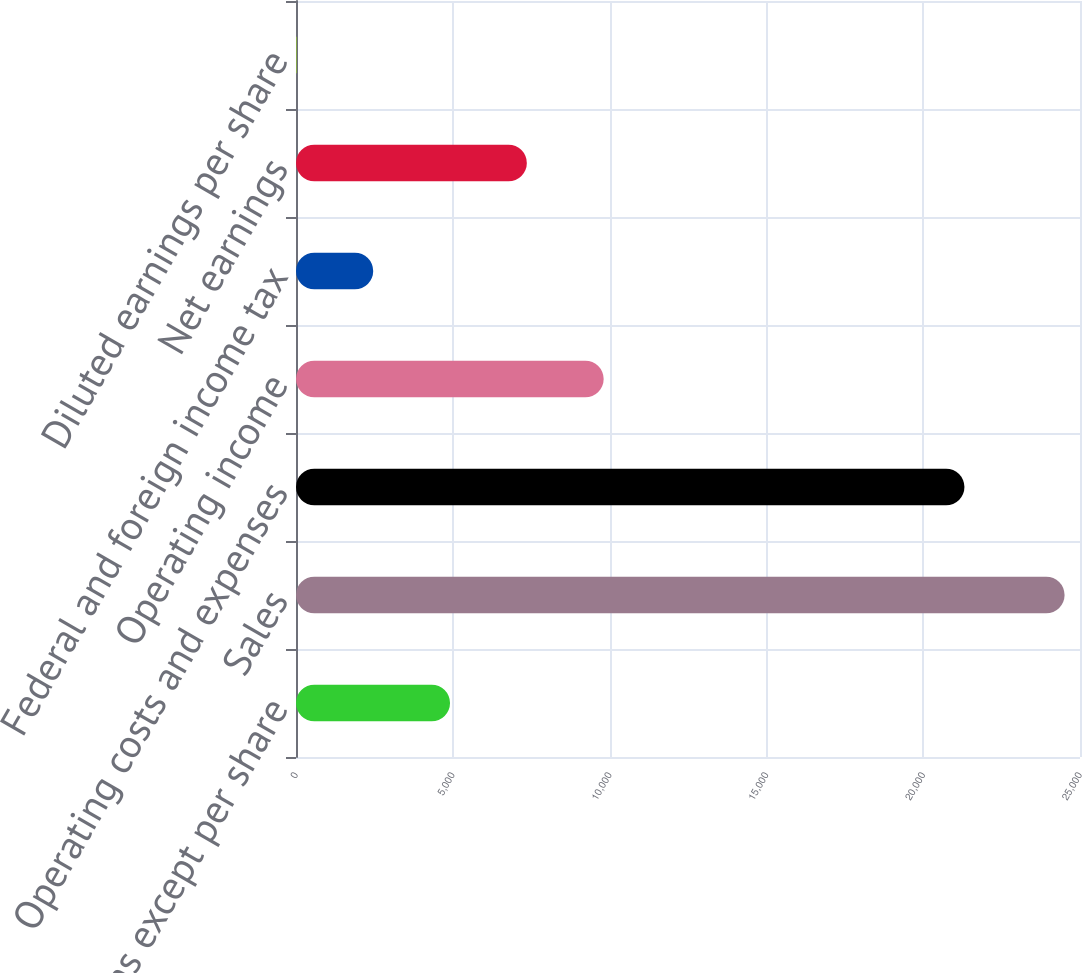Convert chart. <chart><loc_0><loc_0><loc_500><loc_500><bar_chart><fcel>in millions except per share<fcel>Sales<fcel>Operating costs and expenses<fcel>Operating income<fcel>Federal and foreign income tax<fcel>Net earnings<fcel>Diluted earnings per share<nl><fcel>4911.35<fcel>24508<fcel>21315<fcel>9810.51<fcel>2461.77<fcel>7360.93<fcel>12.19<nl></chart> 